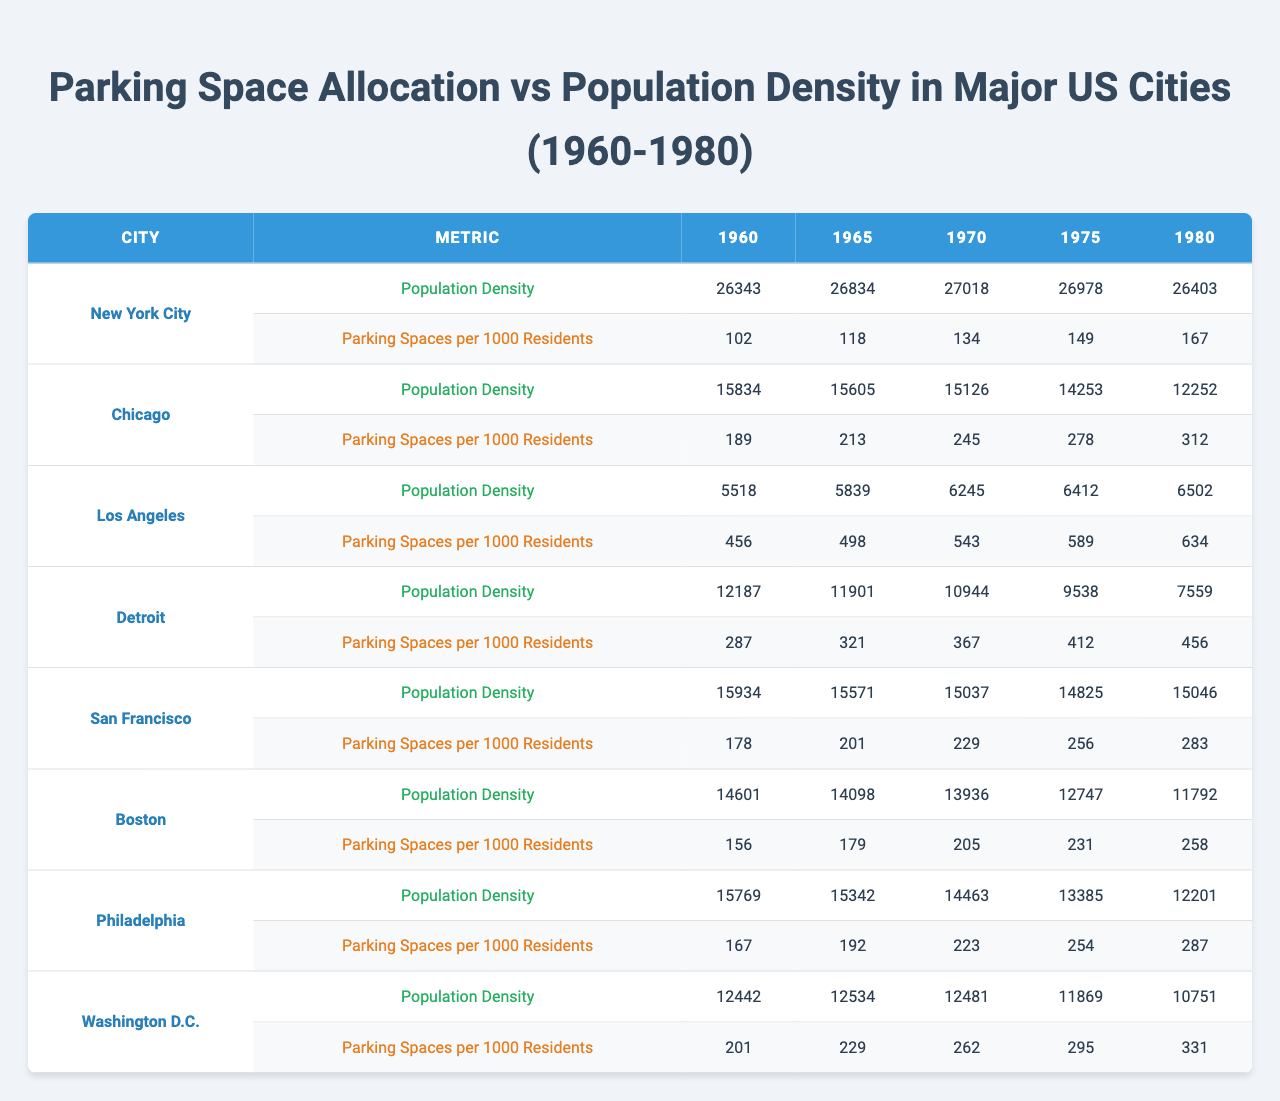What was the population density of Chicago in 1970? Referring to the table, under the section for Chicago, the population density data for the year 1970 is listed as 15126.
Answer: 15126 Which city had the highest number of parking spaces per 1000 residents in 1980? Looking at the table for the year 1980, the parking spaces per 1000 residents for each city shows that Chicago had the highest value at 312.
Answer: Chicago What is the difference in parking spaces per 1000 residents between New York City in 1960 and 1980? The values for New York City are 102 for 1960 and 167 for 1980. The difference can be calculated as 167 - 102 = 65.
Answer: 65 Was the parking space allocation increasing in Detroit from 1960 to 1975? In Detroit, parking spaces per 1000 residents increased from 287 in 1960 to 412 in 1975. This indicates an increase, so the answer is yes.
Answer: Yes Which city had the lowest parking spaces per 1000 residents in 1965? The table indicates that San Francisco had the lowest parking spaces per 1000 residents in 1965, with a value of 201.
Answer: San Francisco What was the average parking spaces per 1000 residents across all cities in 1970? First, we sum the parking spaces values for 1970: 134 (NYC) + 245 (Chicago) + 543 (Los Angeles) + 367 (Detroit) + 229 (San Francisco) + 205 (Boston) + 223 (Philadelphia) + 262 (Washington D.C.) = 2108. There are 8 cities, so the average is 2108 / 8 = 263.5.
Answer: 263.5 Did all cities have a decline in population density from 1970 to 1980? Checking the population density values from 1970 to 1980 for each city, we find that Los Angeles and San Francisco did not decline. Hence, the statement is false.
Answer: No What trend can be observed in the parking spaces per 1000 residents for Los Angeles from 1960 to 1980? In Los Angeles, parking spaces per 1000 residents increased from 456 in 1960 to 634 in 1980. This indicates a consistent upward trend across the years.
Answer: Upward trend Which city had the most stable population density across the years from 1960 to 1980? Analyzing the population density data for each city, we find that New York City’s population density hovered around similar values (26343 in 1960 to 26403 in 1980) with minor fluctuations, showing stability compared to others.
Answer: New York City How much did population density in San Francisco change from 1960 to 1980? The population density in San Francisco was 15934 in 1960 and 15046 in 1980. The change can be calculated as 15046 - 15934 = -888, indicating a decline.
Answer: Declined by 888 